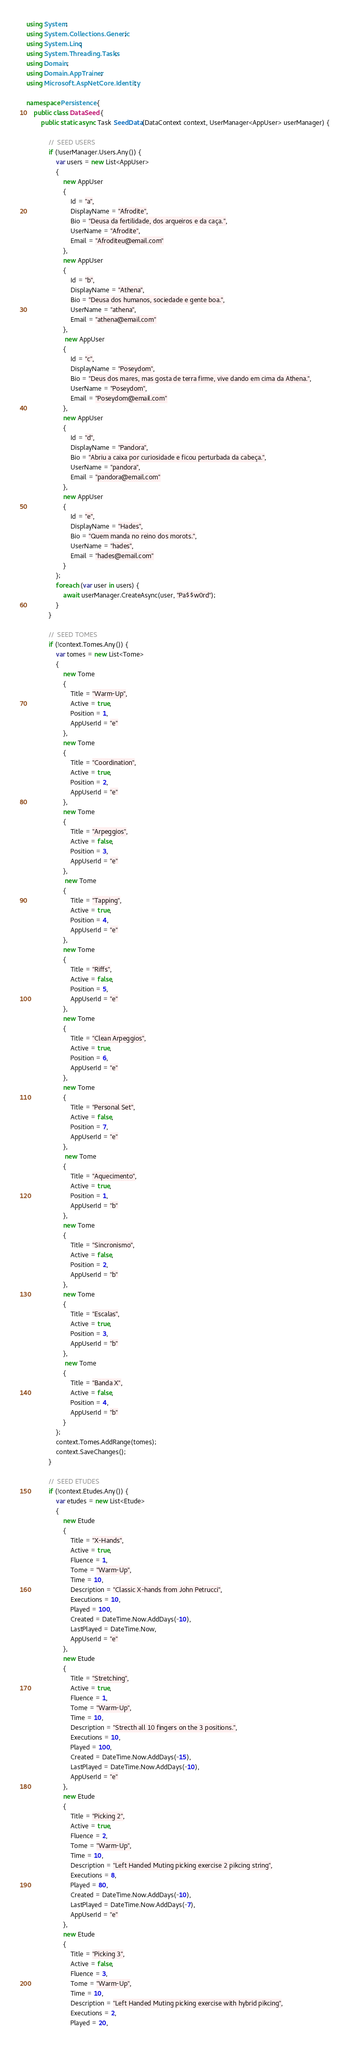Convert code to text. <code><loc_0><loc_0><loc_500><loc_500><_C#_>using System;
using System.Collections.Generic;
using System.Linq;
using System.Threading.Tasks;
using Domain;
using Domain.AppTrainer;
using Microsoft.AspNetCore.Identity;

namespace Persistence {
    public class DataSeed {
        public static async Task SeedData(DataContext context, UserManager<AppUser> userManager) {

            //  SEED USERS
            if (!userManager.Users.Any()) {
                var users = new List<AppUser>
                {
                    new AppUser
                    {
                        Id = "a",
                        DisplayName = "Afrodite",
                        Bio = "Deusa da fertilidade, dos arqueiros e da caça.",
                        UserName = "Afrodite",
                        Email = "Afroditeu@email.com"
                    },
                    new AppUser
                    {
                        Id = "b",
                        DisplayName = "Athena",
                        Bio = "Deusa dos humanos, sociedade e gente boa.",
                        UserName = "athena",
                        Email = "athena@email.com"
                    },
                     new AppUser
                    {
                        Id = "c",
                        DisplayName = "Poseydom",
                        Bio = "Deus dos mares, mas gosta de terra firme, vive dando em cima da Athena.",
                        UserName = "Poseydom",
                        Email = "Poseydom@email.com"
                    },
                    new AppUser
                    {
                        Id = "d",
                        DisplayName = "Pandora",
                        Bio = "Abriu a caixa por curiosidade e ficou perturbada da cabeça.",
                        UserName = "pandora",
                        Email = "pandora@email.com"
                    },
                    new AppUser
                    {
                        Id = "e",
                        DisplayName = "Hades",
                        Bio = "Quem manda no reino dos morots.",
                        UserName = "hades",
                        Email = "hades@email.com"
                    }
                };
                foreach (var user in users) {
                    await userManager.CreateAsync(user, "Pa$$w0rd");
                }
            }

            //  SEED TOMES
            if (!context.Tomes.Any()) {
                var tomes = new List<Tome>
                {
                    new Tome
                    {
                        Title = "Warm-Up",
                        Active = true,
                        Position = 1,
                        AppUserId = "e"
                    },
                    new Tome
                    {
                        Title = "Coordination",
                        Active = true,
                        Position = 2,
                        AppUserId = "e"
                    },
                    new Tome
                    {
                        Title = "Arpeggios",
                        Active = false,
                        Position = 3,
                        AppUserId = "e"
                    },
                     new Tome
                    {
                        Title = "Tapping",
                        Active = true,
                        Position = 4,
                        AppUserId = "e"
                    },
                    new Tome
                    {
                        Title = "Riffs",
                        Active = false,
                        Position = 5,
                        AppUserId = "e"
                    },
                    new Tome
                    {
                        Title = "Clean Arpeggios",
                        Active = true,
                        Position = 6,
                        AppUserId = "e"
                    },
                    new Tome
                    {
                        Title = "Personal Set",
                        Active = false,
                        Position = 7,
                        AppUserId = "e"
                    },
                     new Tome
                    {
                        Title = "Aquecimento",
                        Active = true,
                        Position = 1,
                        AppUserId = "b"
                    },
                    new Tome
                    {
                        Title = "Sincronismo",
                        Active = false,
                        Position = 2,
                        AppUserId = "b"
                    },
                    new Tome
                    {
                        Title = "Escalas",
                        Active = true,
                        Position = 3,
                        AppUserId = "b"
                    },
                     new Tome
                    {
                        Title = "Banda X",
                        Active = false,
                        Position = 4,
                        AppUserId = "b"
                    }
                };
                context.Tomes.AddRange(tomes);
                context.SaveChanges();
            }

            //  SEED ETUDES
            if (!context.Etudes.Any()) {
                var etudes = new List<Etude>
                {
                    new Etude
                    {
                        Title = "X-Hands",
                        Active = true,
                        Fluence = 1,
                        Tome = "Warm-Up",
                        Time = 10,
                        Description = "Classic X-hands from John Petrucci",
                        Executions = 10,
                        Played = 100,
                        Created = DateTime.Now.AddDays(-10),
                        LastPlayed = DateTime.Now,
                        AppUserId = "e"
                    },
                    new Etude
                    {
                        Title = "Stretching",
                        Active = true,
                        Fluence = 1,
                        Tome = "Warm-Up",
                        Time = 10,
                        Description = "Strecth all 10 fingers on the 3 positions.",
                        Executions = 10,
                        Played = 100,
                        Created = DateTime.Now.AddDays(-15),
                        LastPlayed = DateTime.Now.AddDays(-10),
                        AppUserId = "e"
                    },
                    new Etude
                    {
                        Title = "Picking 2",
                        Active = true,
                        Fluence = 2,
                        Tome = "Warm-Up",
                        Time = 10,
                        Description = "Left Handed Muting picking exercise 2 pikcing string",
                        Executions = 8,
                        Played = 80,
                        Created = DateTime.Now.AddDays(-10),
                        LastPlayed = DateTime.Now.AddDays(-7),
                        AppUserId = "e"
                    },
                    new Etude
                    {
                        Title = "Picking 3",
                        Active = false,
                        Fluence = 3,
                        Tome = "Warm-Up",
                        Time = 10,
                        Description = "Left Handed Muting picking exercise with hybrid pikcing",
                        Executions = 2,
                        Played = 20,</code> 